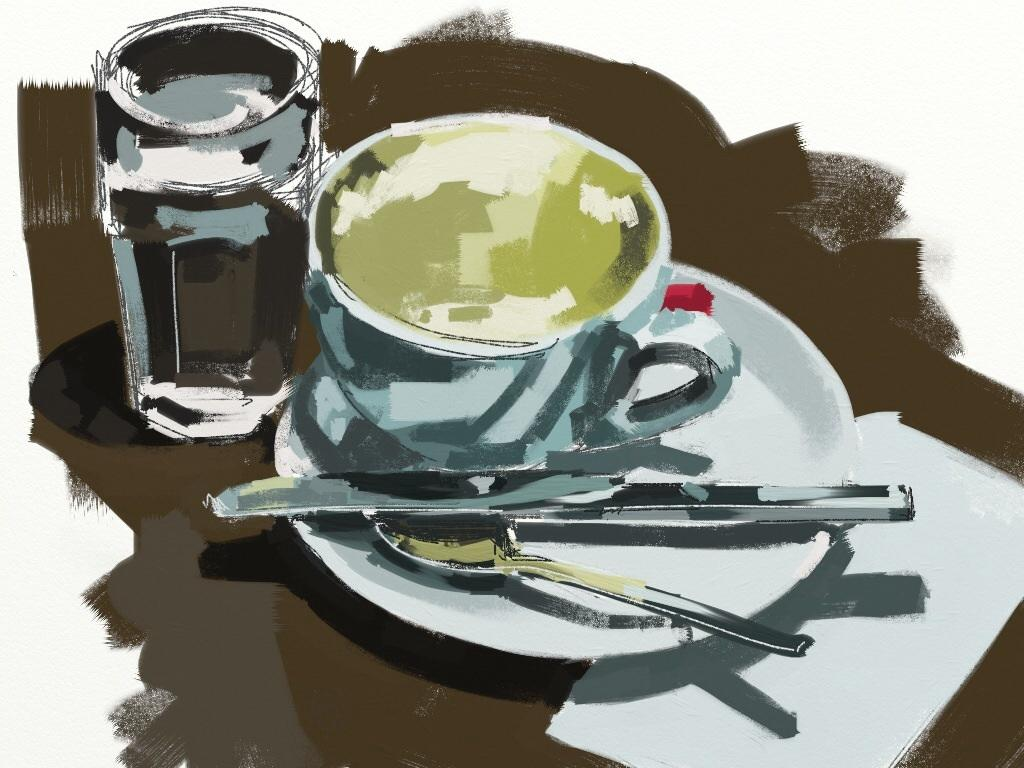What is the main subject of the image? There is a painting in the image. What other objects can be seen in the image? There is a glass, a cup with a saucer, a spoon, and a knife in the image. What type of wilderness can be seen in the background of the painting? There is no wilderness visible in the image, as the focus is on the painting and the objects surrounding it. 